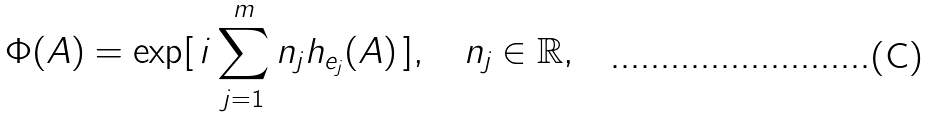<formula> <loc_0><loc_0><loc_500><loc_500>\Phi ( A ) = \exp [ \, i \sum _ { j = 1 } ^ { m } n _ { j } h _ { e _ { j } } ( A ) \, ] , \quad n _ { j } \in \mathbb { R } ,</formula> 